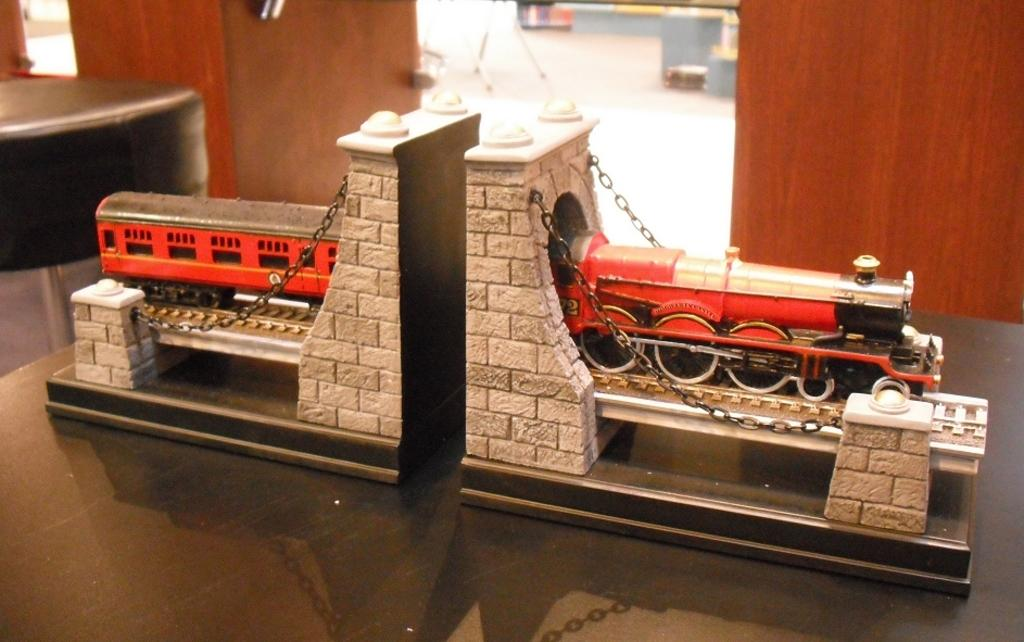What type of toy can be seen in the image? There is a toy train in the image. Are there any other toys or objects related to the train in the image? Yes, there is a toy bridge in the image. Where are the train and bridge located? The train and bridge are placed on a table. What other furniture is visible in the image? There is a chair visible in the image. What material is the wooden object made of? The wooden object is made of wood. What is the train's brother doing in the yard? There is no train's brother or yard present in the image. The image only features a toy train, a toy bridge, a table, a chair, and a wooden object. 